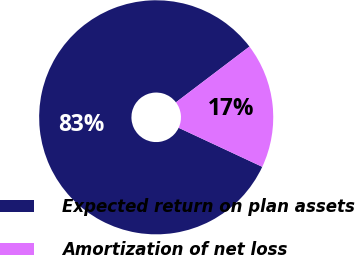Convert chart to OTSL. <chart><loc_0><loc_0><loc_500><loc_500><pie_chart><fcel>Expected return on plan assets<fcel>Amortization of net loss<nl><fcel>82.72%<fcel>17.28%<nl></chart> 